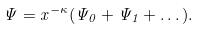Convert formula to latex. <formula><loc_0><loc_0><loc_500><loc_500>\Psi = x ^ { - \kappa } ( \Psi _ { 0 } + \Psi _ { 1 } + \dots ) .</formula> 